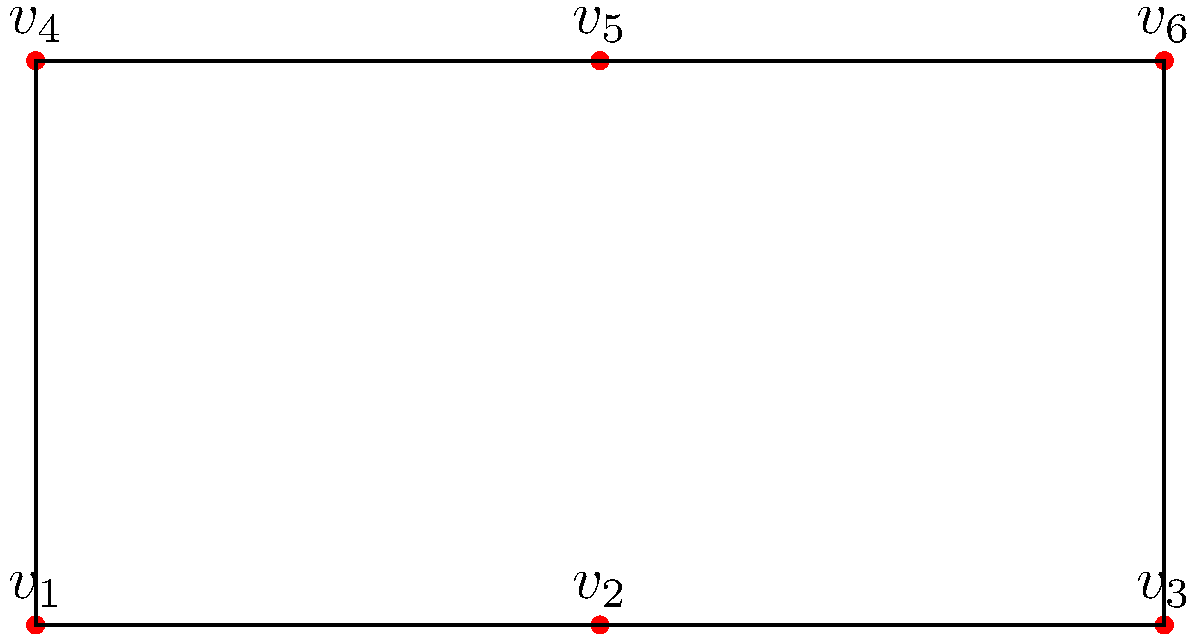In the context of our Nigerian education system, consider the following graph representing connections between six students in a classroom discussion group. Each vertex $v_i$ represents a student, and edges represent communication links between them. How many connected components does this graph have? To determine the number of connected components in this graph, we need to identify groups of vertices that are connected to each other but disconnected from other groups. Let's analyze the graph step by step:

1. We have six vertices: $v_1$, $v_2$, $v_3$, $v_4$, $v_5$, and $v_6$.

2. We can see that there are two distinct groups of connected vertices:
   a) Group 1: $v_1$, $v_2$, $v_3$, $v_4$
   b) Group 2: $v_5$, $v_6$

3. In Group 1:
   - $v_1$ is connected to $v_2$ and $v_4$
   - $v_2$ is connected to $v_1$ and $v_3$
   - $v_3$ is connected to $v_2$
   - $v_4$ is connected to $v_1$

4. In Group 2:
   - $v_5$ is connected to $v_6$
   - $v_6$ is connected to $v_5$

5. There are no connections between Group 1 and Group 2.

6. By definition, a connected component is a maximal connected subgraph. In this case, we have two such subgraphs that are not connected to each other.

Therefore, this graph has 2 connected components.
Answer: 2 